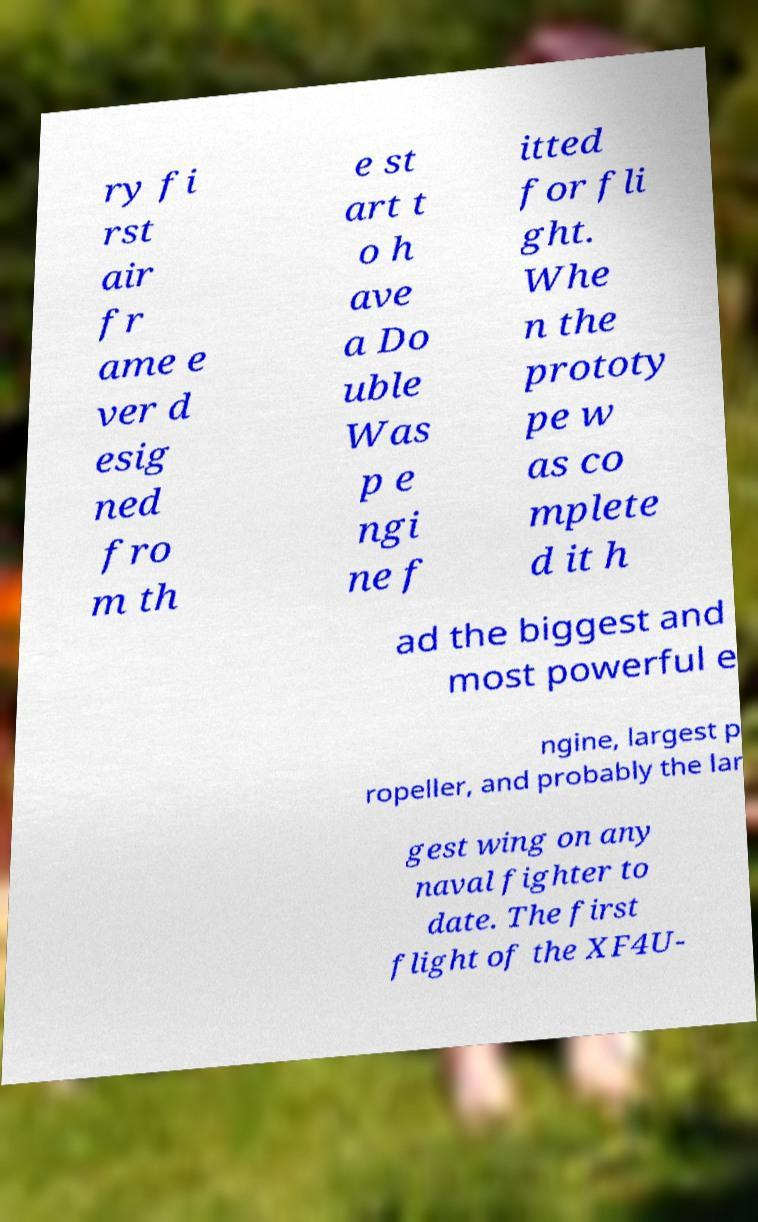Please identify and transcribe the text found in this image. ry fi rst air fr ame e ver d esig ned fro m th e st art t o h ave a Do uble Was p e ngi ne f itted for fli ght. Whe n the prototy pe w as co mplete d it h ad the biggest and most powerful e ngine, largest p ropeller, and probably the lar gest wing on any naval fighter to date. The first flight of the XF4U- 